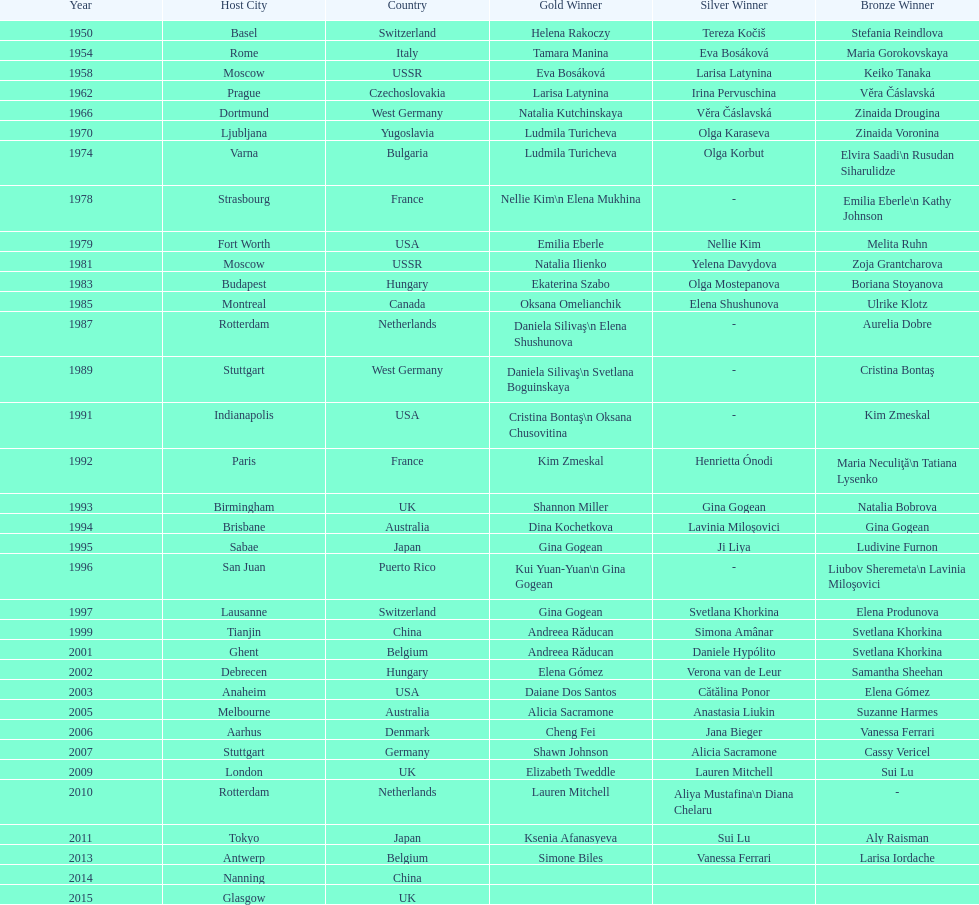Where did the world artistic gymnastics take place before san juan? Sabae. 